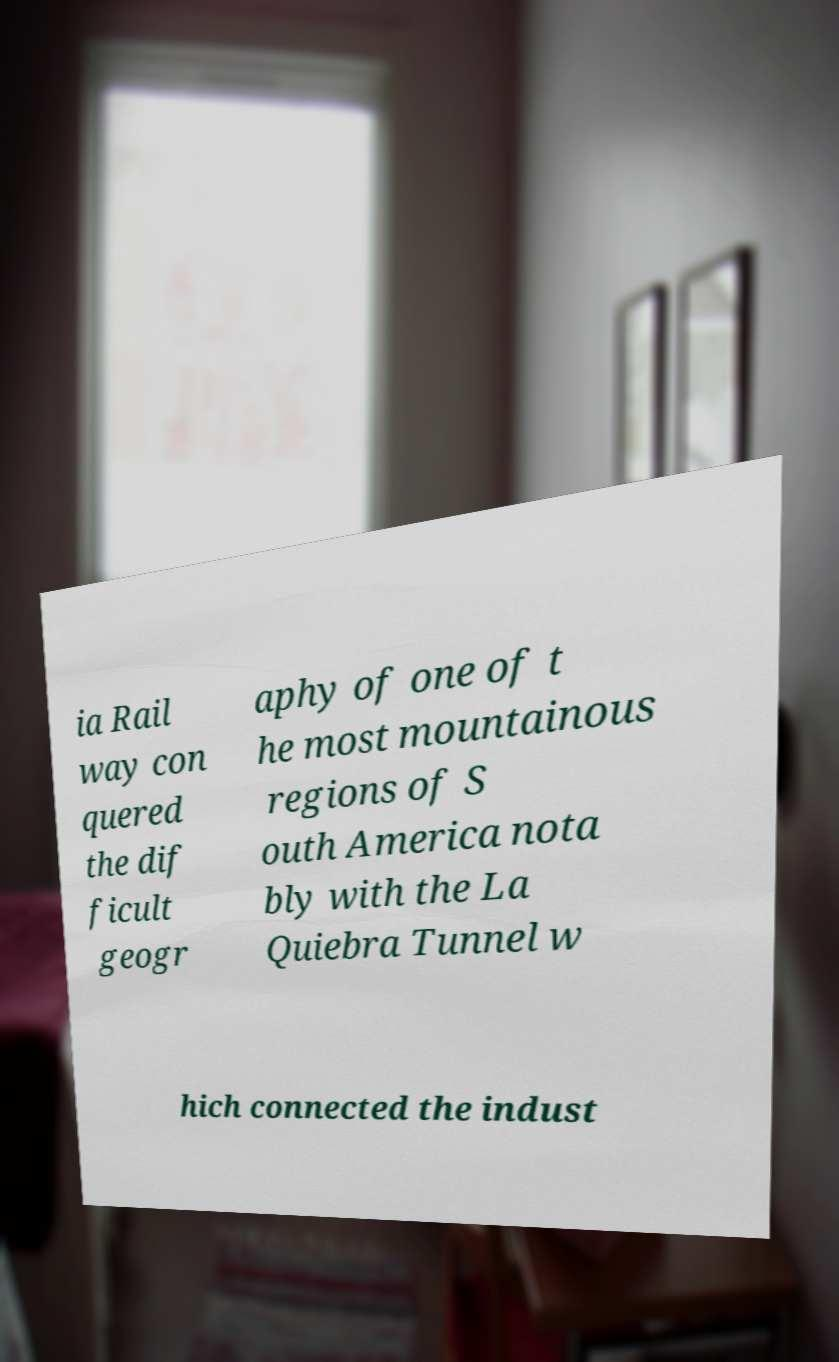There's text embedded in this image that I need extracted. Can you transcribe it verbatim? ia Rail way con quered the dif ficult geogr aphy of one of t he most mountainous regions of S outh America nota bly with the La Quiebra Tunnel w hich connected the indust 